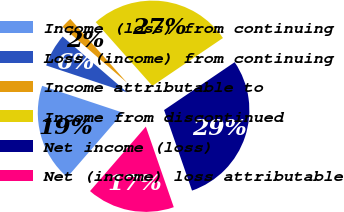Convert chart to OTSL. <chart><loc_0><loc_0><loc_500><loc_500><pie_chart><fcel>Income (loss) from continuing<fcel>Loss (income) from continuing<fcel>Income attributable to<fcel>Income from discontinued<fcel>Net income (loss)<fcel>Net (income) loss attributable<nl><fcel>18.75%<fcel>6.25%<fcel>2.08%<fcel>27.08%<fcel>29.17%<fcel>16.67%<nl></chart> 